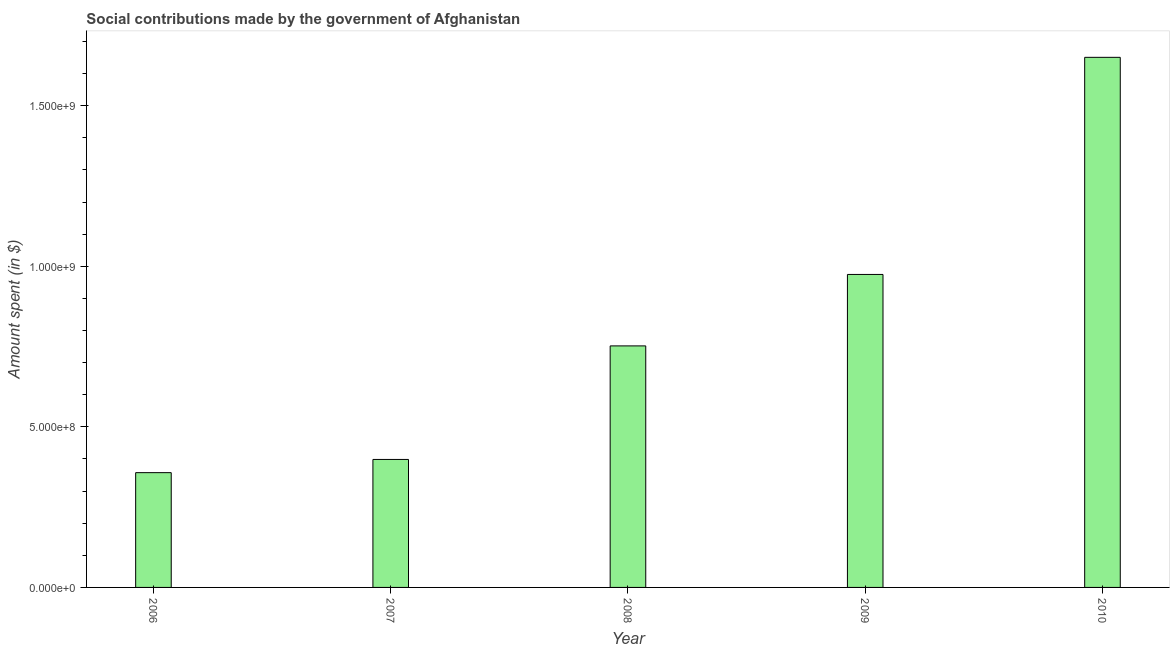Does the graph contain grids?
Provide a succinct answer. No. What is the title of the graph?
Make the answer very short. Social contributions made by the government of Afghanistan. What is the label or title of the Y-axis?
Your answer should be very brief. Amount spent (in $). What is the amount spent in making social contributions in 2008?
Your answer should be very brief. 7.52e+08. Across all years, what is the maximum amount spent in making social contributions?
Ensure brevity in your answer.  1.65e+09. Across all years, what is the minimum amount spent in making social contributions?
Give a very brief answer. 3.57e+08. In which year was the amount spent in making social contributions minimum?
Keep it short and to the point. 2006. What is the sum of the amount spent in making social contributions?
Your response must be concise. 4.13e+09. What is the difference between the amount spent in making social contributions in 2006 and 2008?
Give a very brief answer. -3.95e+08. What is the average amount spent in making social contributions per year?
Make the answer very short. 8.27e+08. What is the median amount spent in making social contributions?
Keep it short and to the point. 7.52e+08. In how many years, is the amount spent in making social contributions greater than 1500000000 $?
Your answer should be compact. 1. What is the ratio of the amount spent in making social contributions in 2006 to that in 2008?
Offer a very short reply. 0.47. Is the difference between the amount spent in making social contributions in 2006 and 2008 greater than the difference between any two years?
Your response must be concise. No. What is the difference between the highest and the second highest amount spent in making social contributions?
Offer a terse response. 6.76e+08. Is the sum of the amount spent in making social contributions in 2006 and 2009 greater than the maximum amount spent in making social contributions across all years?
Ensure brevity in your answer.  No. What is the difference between the highest and the lowest amount spent in making social contributions?
Your answer should be compact. 1.29e+09. How many bars are there?
Your answer should be very brief. 5. Are all the bars in the graph horizontal?
Give a very brief answer. No. How many years are there in the graph?
Give a very brief answer. 5. What is the difference between two consecutive major ticks on the Y-axis?
Offer a terse response. 5.00e+08. What is the Amount spent (in $) of 2006?
Your answer should be very brief. 3.57e+08. What is the Amount spent (in $) in 2007?
Your answer should be compact. 3.98e+08. What is the Amount spent (in $) of 2008?
Your response must be concise. 7.52e+08. What is the Amount spent (in $) of 2009?
Ensure brevity in your answer.  9.74e+08. What is the Amount spent (in $) in 2010?
Offer a terse response. 1.65e+09. What is the difference between the Amount spent (in $) in 2006 and 2007?
Offer a very short reply. -4.11e+07. What is the difference between the Amount spent (in $) in 2006 and 2008?
Make the answer very short. -3.95e+08. What is the difference between the Amount spent (in $) in 2006 and 2009?
Give a very brief answer. -6.17e+08. What is the difference between the Amount spent (in $) in 2006 and 2010?
Offer a terse response. -1.29e+09. What is the difference between the Amount spent (in $) in 2007 and 2008?
Your answer should be compact. -3.54e+08. What is the difference between the Amount spent (in $) in 2007 and 2009?
Offer a very short reply. -5.76e+08. What is the difference between the Amount spent (in $) in 2007 and 2010?
Provide a short and direct response. -1.25e+09. What is the difference between the Amount spent (in $) in 2008 and 2009?
Your response must be concise. -2.22e+08. What is the difference between the Amount spent (in $) in 2008 and 2010?
Ensure brevity in your answer.  -8.98e+08. What is the difference between the Amount spent (in $) in 2009 and 2010?
Your answer should be very brief. -6.76e+08. What is the ratio of the Amount spent (in $) in 2006 to that in 2007?
Your answer should be very brief. 0.9. What is the ratio of the Amount spent (in $) in 2006 to that in 2008?
Make the answer very short. 0.47. What is the ratio of the Amount spent (in $) in 2006 to that in 2009?
Give a very brief answer. 0.37. What is the ratio of the Amount spent (in $) in 2006 to that in 2010?
Your answer should be compact. 0.22. What is the ratio of the Amount spent (in $) in 2007 to that in 2008?
Your response must be concise. 0.53. What is the ratio of the Amount spent (in $) in 2007 to that in 2009?
Offer a very short reply. 0.41. What is the ratio of the Amount spent (in $) in 2007 to that in 2010?
Offer a very short reply. 0.24. What is the ratio of the Amount spent (in $) in 2008 to that in 2009?
Ensure brevity in your answer.  0.77. What is the ratio of the Amount spent (in $) in 2008 to that in 2010?
Keep it short and to the point. 0.46. What is the ratio of the Amount spent (in $) in 2009 to that in 2010?
Offer a terse response. 0.59. 